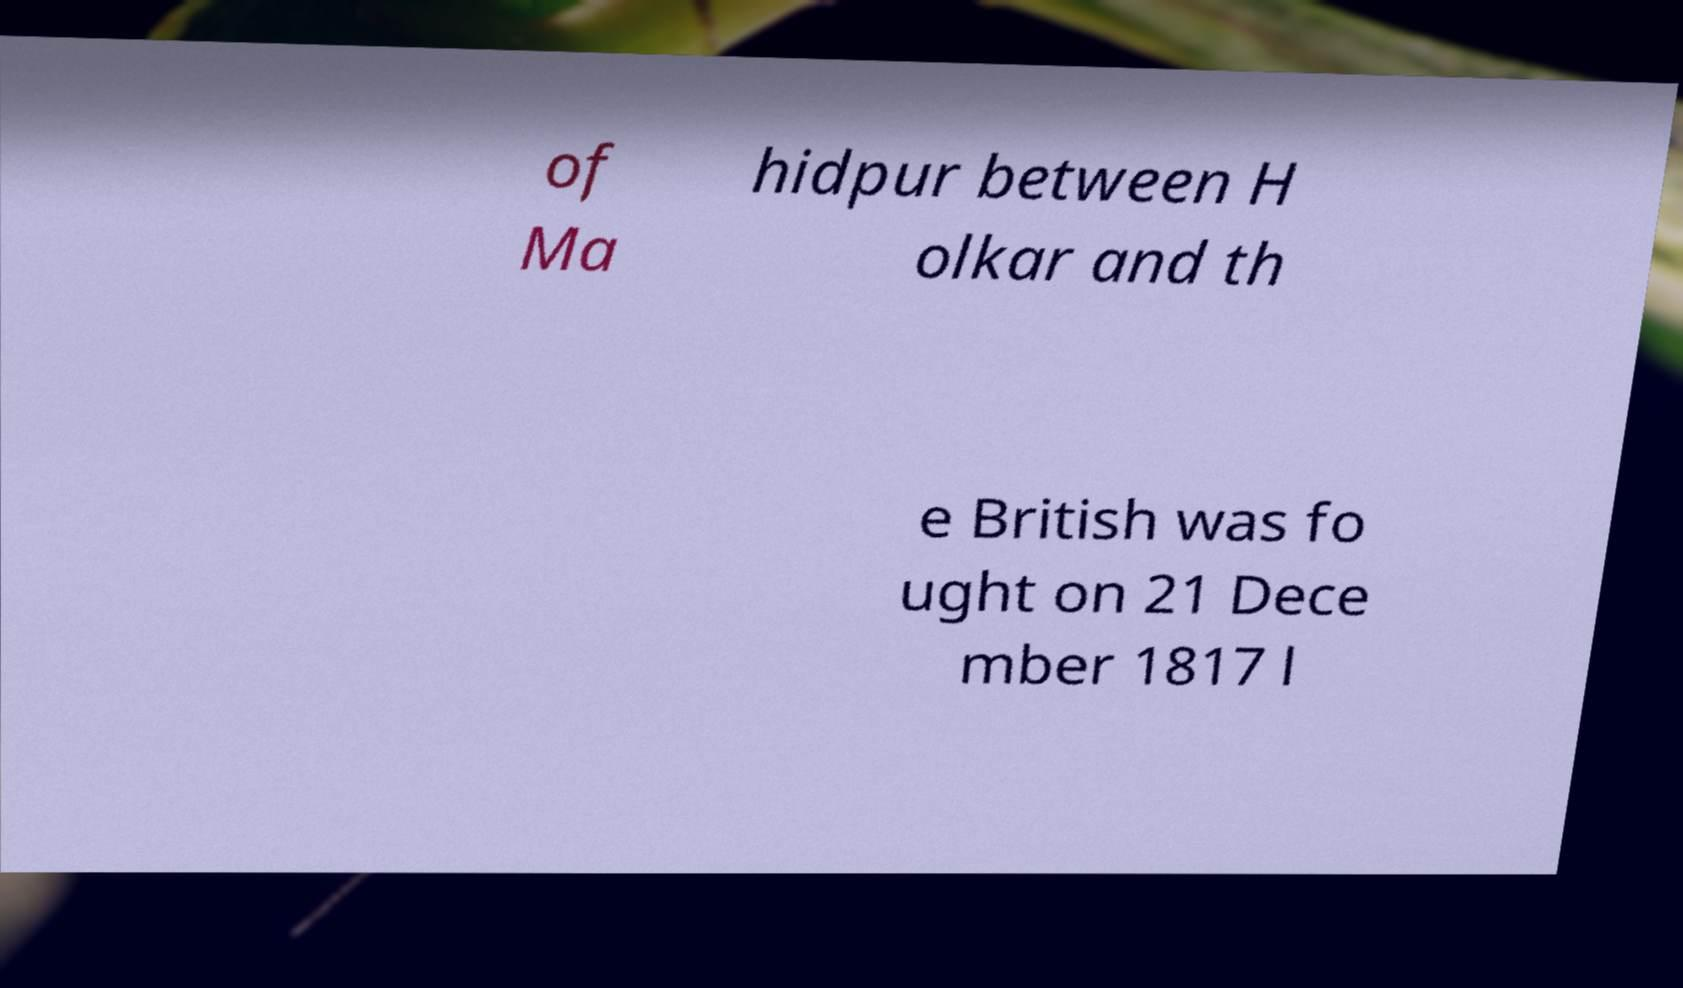Please identify and transcribe the text found in this image. of Ma hidpur between H olkar and th e British was fo ught on 21 Dece mber 1817 l 